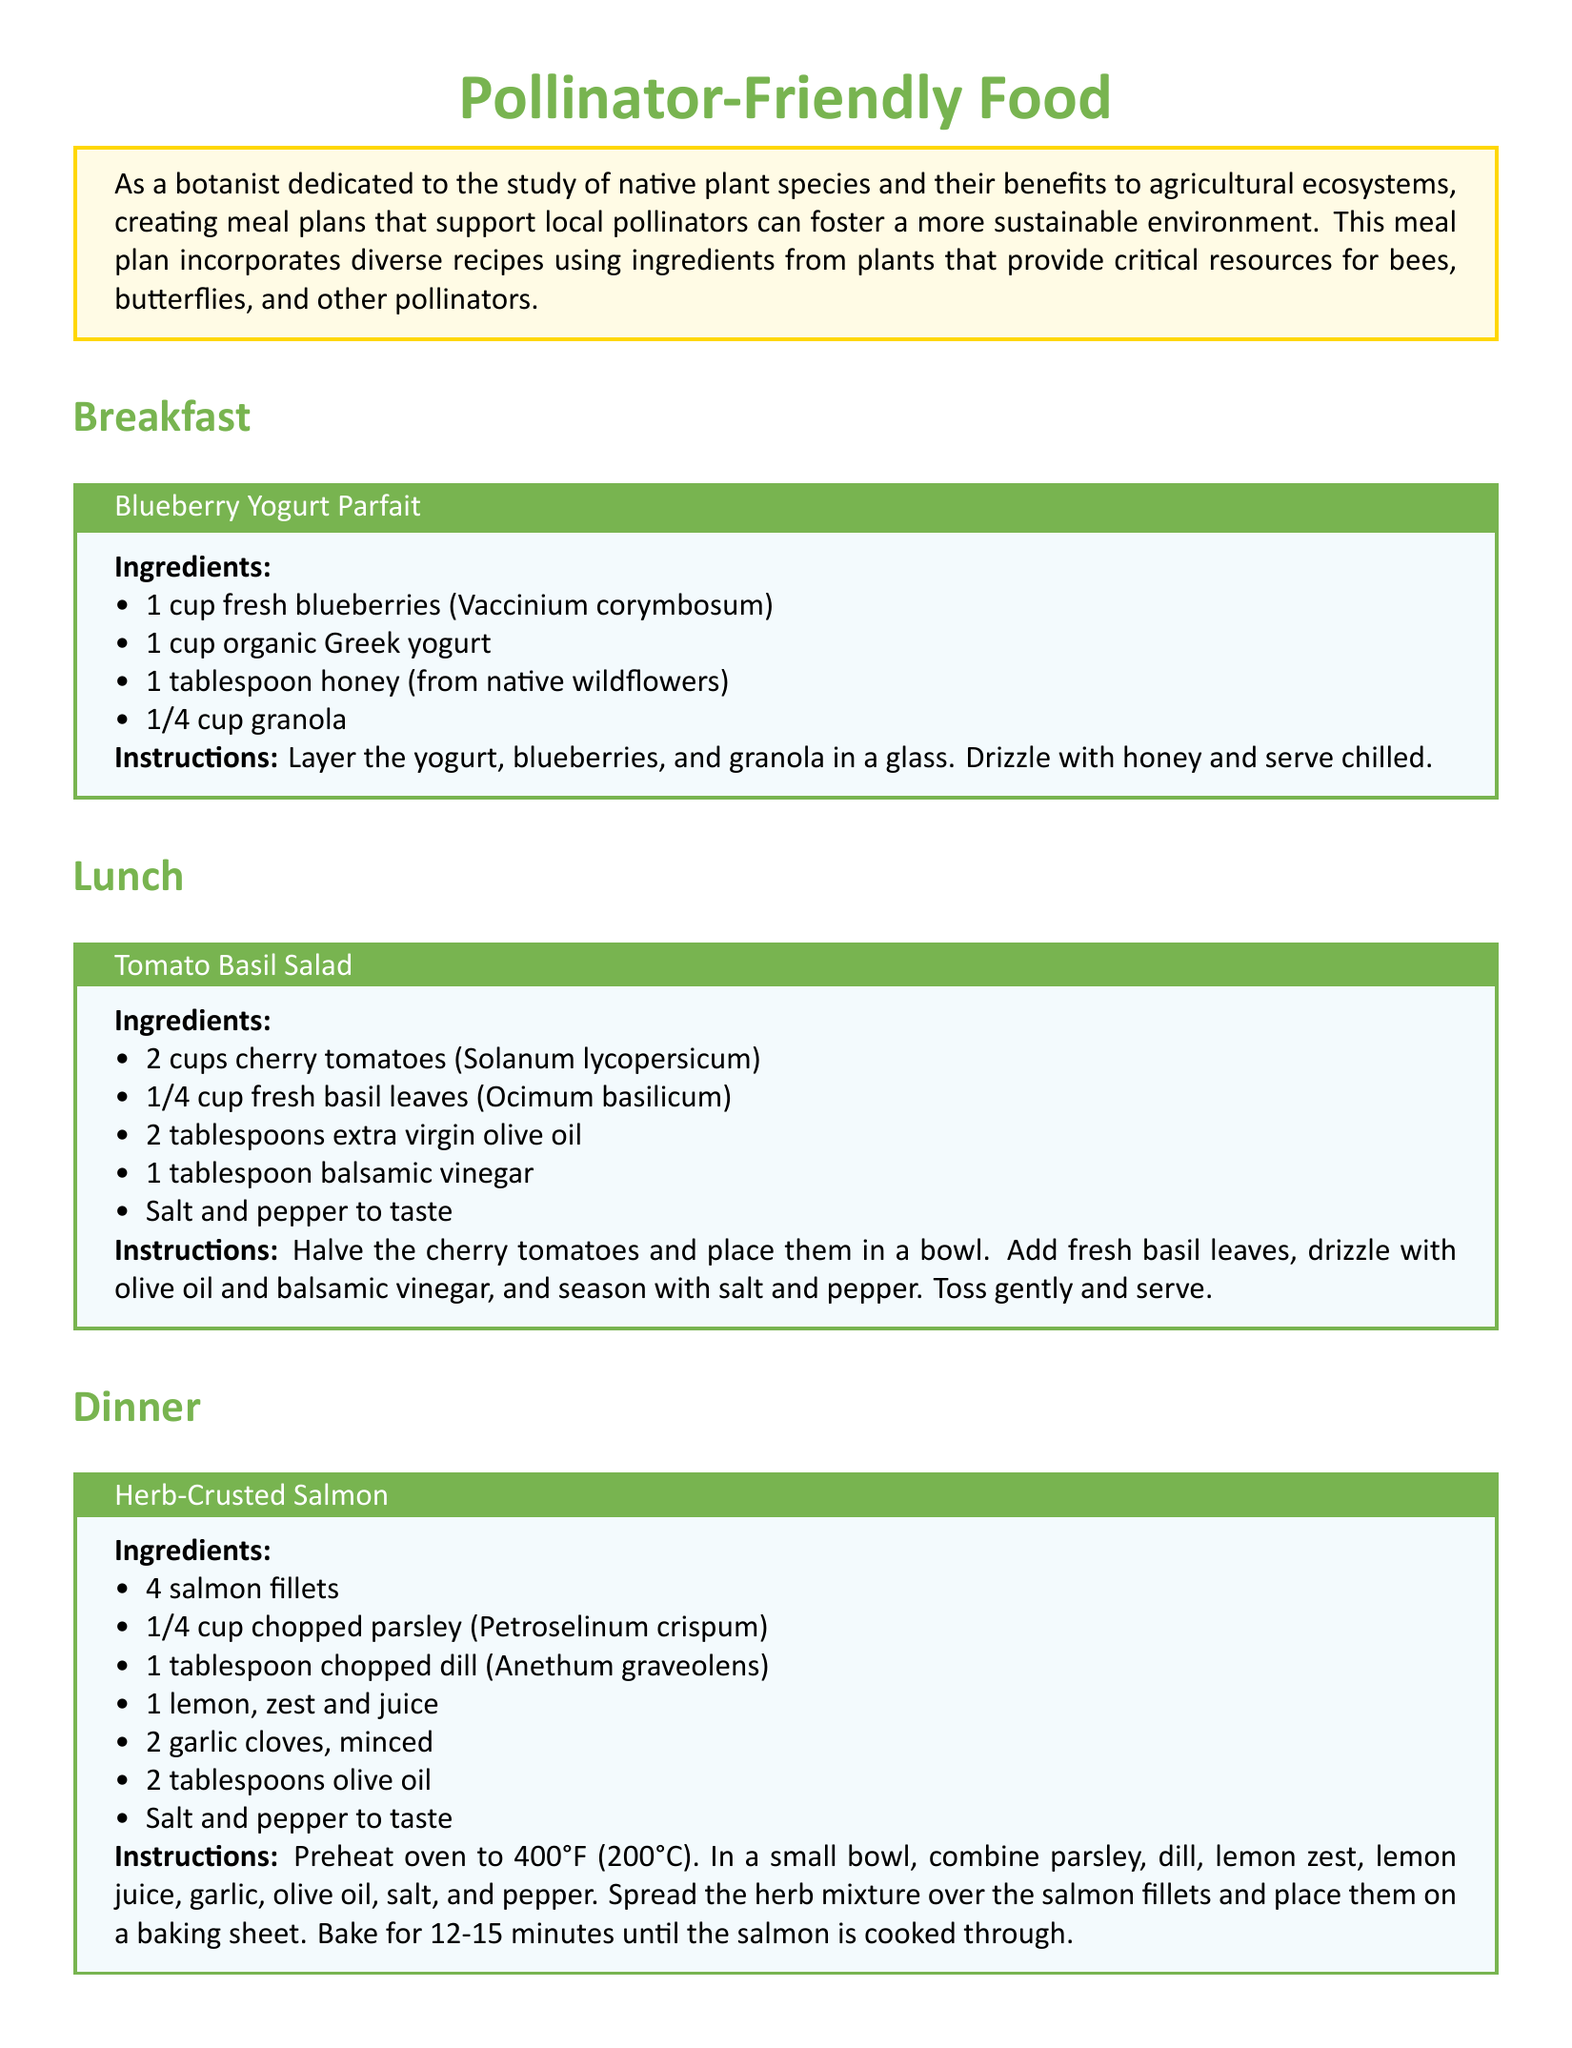What is the title of the document? The title is prominently displayed at the top of the document.
Answer: Pollinator-Friendly Food How many recipes are provided for meals? The document includes recipes for breakfast, lunch, dinner, and a snack, totaling four recipes.
Answer: 4 What type of yogurt is used in the breakfast recipe? The breakfast recipe specifies the type of yogurt to be used.
Answer: Greek yogurt What is the key ingredient in the Tomato Basil Salad? The main ingredients in the salad are listed, highlighting the key ingredient.
Answer: Cherry tomatoes How long should the salmon be baked? The instructions for the dinner recipe include the baking time for salmon.
Answer: 12-15 minutes What is the primary purpose of the meal plan? The introductory paragraph explains the goal of the meal plan.
Answer: Support local pollinators What ingredient in the breakfast recipe is sourced from native wildflowers? The breakfast recipe includes a specific ingredient that relates to local flora.
Answer: Honey How many cups of dried cranberries are in the snack recipe? The ingredient list for the snack details the amount of dried cranberries needed.
Answer: 1/2 cup What is the color theme of the snack recipe box? Each recipe box has a distinctive color that indicates the theme.
Answer: Sky blue 